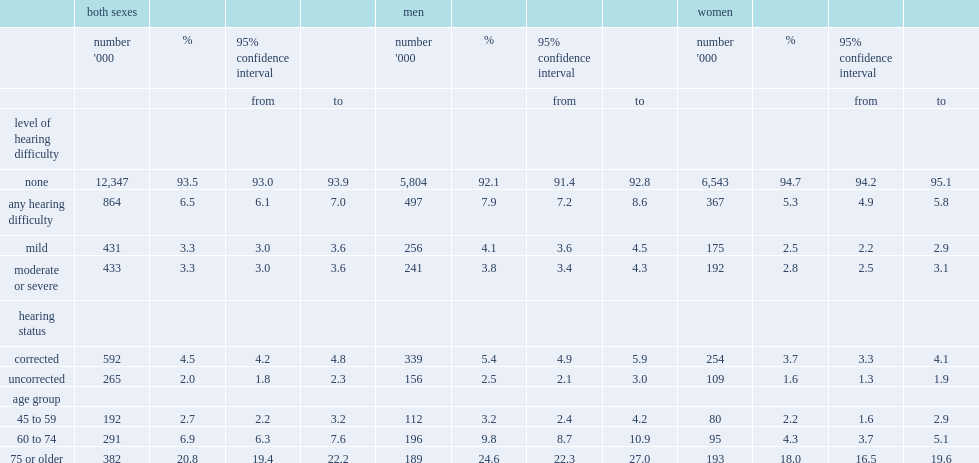Hearing impairment was more common at older ages, what was the percent among those aged 75 or older? 20.8. Which gender were generally more likely to have a hearing impairment, men or women? Men. 